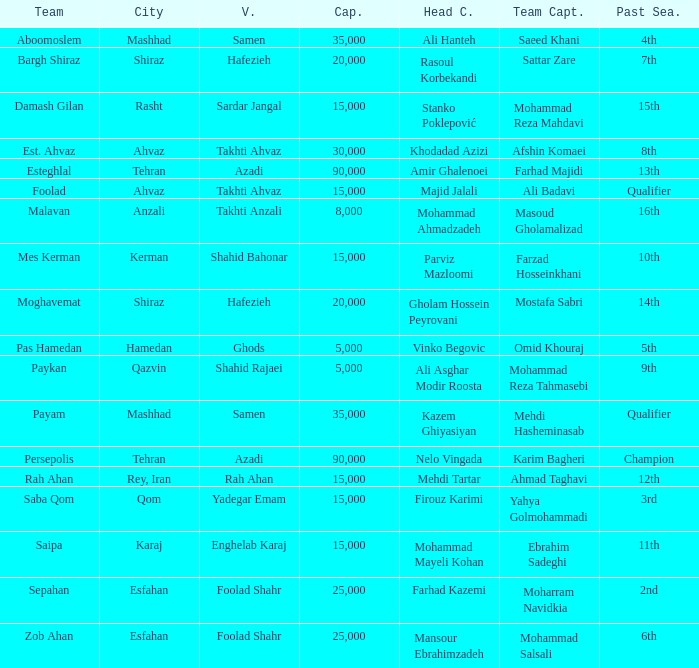What is the Capacity of the Venue of Head Coach Farhad Kazemi? 25000.0. 